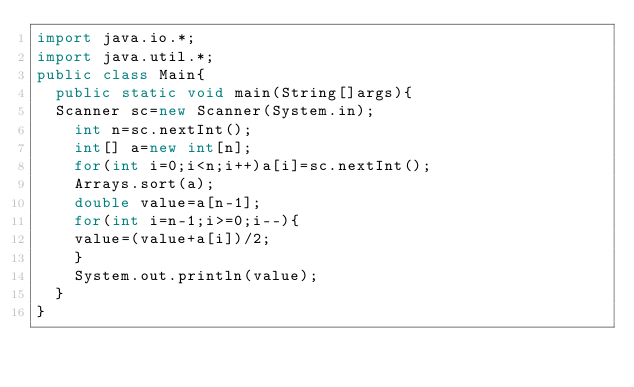<code> <loc_0><loc_0><loc_500><loc_500><_Java_>import java.io.*;
import java.util.*;
public class Main{
  public static void main(String[]args){
  Scanner sc=new Scanner(System.in);
    int n=sc.nextInt();
    int[] a=new int[n];
  	for(int i=0;i<n;i++)a[i]=sc.nextInt();
    Arrays.sort(a);
    double value=a[n-1];
    for(int i=n-1;i>=0;i--){
   	value=(value+a[i])/2;
    }
    System.out.println(value);
  }
}</code> 